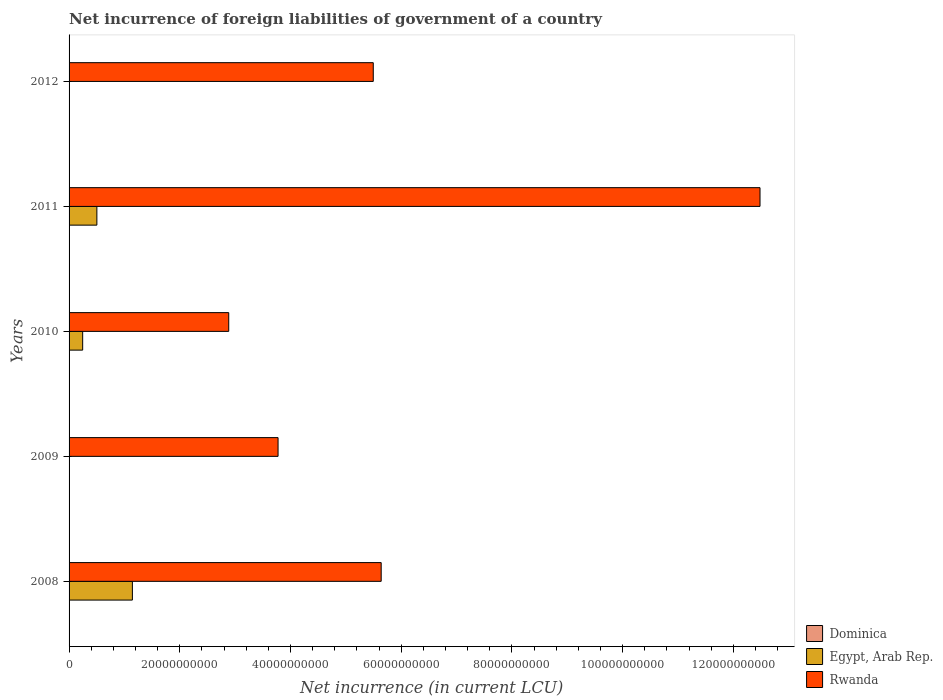How many groups of bars are there?
Ensure brevity in your answer.  5. How many bars are there on the 4th tick from the bottom?
Make the answer very short. 3. What is the net incurrence of foreign liabilities in Egypt, Arab Rep. in 2008?
Provide a short and direct response. 1.14e+1. Across all years, what is the maximum net incurrence of foreign liabilities in Rwanda?
Your answer should be very brief. 1.25e+11. Across all years, what is the minimum net incurrence of foreign liabilities in Dominica?
Your answer should be compact. 0. In which year was the net incurrence of foreign liabilities in Dominica maximum?
Give a very brief answer. 2012. What is the total net incurrence of foreign liabilities in Dominica in the graph?
Give a very brief answer. 1.79e+08. What is the difference between the net incurrence of foreign liabilities in Egypt, Arab Rep. in 2008 and that in 2010?
Your answer should be compact. 8.98e+09. What is the difference between the net incurrence of foreign liabilities in Rwanda in 2009 and the net incurrence of foreign liabilities in Dominica in 2012?
Provide a succinct answer. 3.77e+1. What is the average net incurrence of foreign liabilities in Egypt, Arab Rep. per year?
Your answer should be very brief. 3.78e+09. In the year 2010, what is the difference between the net incurrence of foreign liabilities in Dominica and net incurrence of foreign liabilities in Rwanda?
Your answer should be very brief. -2.88e+1. In how many years, is the net incurrence of foreign liabilities in Rwanda greater than 104000000000 LCU?
Make the answer very short. 1. What is the ratio of the net incurrence of foreign liabilities in Rwanda in 2009 to that in 2011?
Your answer should be very brief. 0.3. What is the difference between the highest and the second highest net incurrence of foreign liabilities in Egypt, Arab Rep.?
Give a very brief answer. 6.42e+09. What is the difference between the highest and the lowest net incurrence of foreign liabilities in Dominica?
Make the answer very short. 7.28e+07. Is the sum of the net incurrence of foreign liabilities in Dominica in 2009 and 2011 greater than the maximum net incurrence of foreign liabilities in Egypt, Arab Rep. across all years?
Your answer should be very brief. No. Are all the bars in the graph horizontal?
Provide a short and direct response. Yes. How many years are there in the graph?
Keep it short and to the point. 5. What is the difference between two consecutive major ticks on the X-axis?
Your answer should be compact. 2.00e+1. Are the values on the major ticks of X-axis written in scientific E-notation?
Offer a terse response. No. Does the graph contain any zero values?
Ensure brevity in your answer.  Yes. Where does the legend appear in the graph?
Provide a succinct answer. Bottom right. How many legend labels are there?
Make the answer very short. 3. What is the title of the graph?
Give a very brief answer. Net incurrence of foreign liabilities of government of a country. Does "Papua New Guinea" appear as one of the legend labels in the graph?
Offer a terse response. No. What is the label or title of the X-axis?
Make the answer very short. Net incurrence (in current LCU). What is the Net incurrence (in current LCU) in Egypt, Arab Rep. in 2008?
Make the answer very short. 1.14e+1. What is the Net incurrence (in current LCU) of Rwanda in 2008?
Ensure brevity in your answer.  5.64e+1. What is the Net incurrence (in current LCU) of Dominica in 2009?
Make the answer very short. 3.07e+07. What is the Net incurrence (in current LCU) in Egypt, Arab Rep. in 2009?
Offer a very short reply. 0. What is the Net incurrence (in current LCU) of Rwanda in 2009?
Offer a very short reply. 3.78e+1. What is the Net incurrence (in current LCU) in Dominica in 2010?
Give a very brief answer. 4.80e+07. What is the Net incurrence (in current LCU) of Egypt, Arab Rep. in 2010?
Offer a terse response. 2.46e+09. What is the Net incurrence (in current LCU) in Rwanda in 2010?
Provide a short and direct response. 2.88e+1. What is the Net incurrence (in current LCU) in Dominica in 2011?
Offer a very short reply. 2.72e+07. What is the Net incurrence (in current LCU) in Egypt, Arab Rep. in 2011?
Your response must be concise. 5.02e+09. What is the Net incurrence (in current LCU) in Rwanda in 2011?
Provide a succinct answer. 1.25e+11. What is the Net incurrence (in current LCU) of Dominica in 2012?
Offer a terse response. 7.28e+07. What is the Net incurrence (in current LCU) of Rwanda in 2012?
Make the answer very short. 5.49e+1. Across all years, what is the maximum Net incurrence (in current LCU) in Dominica?
Ensure brevity in your answer.  7.28e+07. Across all years, what is the maximum Net incurrence (in current LCU) in Egypt, Arab Rep.?
Provide a short and direct response. 1.14e+1. Across all years, what is the maximum Net incurrence (in current LCU) in Rwanda?
Your answer should be very brief. 1.25e+11. Across all years, what is the minimum Net incurrence (in current LCU) of Egypt, Arab Rep.?
Keep it short and to the point. 0. Across all years, what is the minimum Net incurrence (in current LCU) in Rwanda?
Provide a short and direct response. 2.88e+1. What is the total Net incurrence (in current LCU) of Dominica in the graph?
Offer a very short reply. 1.79e+08. What is the total Net incurrence (in current LCU) of Egypt, Arab Rep. in the graph?
Provide a short and direct response. 1.89e+1. What is the total Net incurrence (in current LCU) of Rwanda in the graph?
Your answer should be compact. 3.03e+11. What is the difference between the Net incurrence (in current LCU) of Rwanda in 2008 and that in 2009?
Keep it short and to the point. 1.86e+1. What is the difference between the Net incurrence (in current LCU) in Egypt, Arab Rep. in 2008 and that in 2010?
Your response must be concise. 8.98e+09. What is the difference between the Net incurrence (in current LCU) of Rwanda in 2008 and that in 2010?
Offer a very short reply. 2.75e+1. What is the difference between the Net incurrence (in current LCU) of Egypt, Arab Rep. in 2008 and that in 2011?
Offer a terse response. 6.42e+09. What is the difference between the Net incurrence (in current LCU) of Rwanda in 2008 and that in 2011?
Offer a very short reply. -6.84e+1. What is the difference between the Net incurrence (in current LCU) of Rwanda in 2008 and that in 2012?
Your answer should be compact. 1.43e+09. What is the difference between the Net incurrence (in current LCU) in Dominica in 2009 and that in 2010?
Your answer should be very brief. -1.73e+07. What is the difference between the Net incurrence (in current LCU) of Rwanda in 2009 and that in 2010?
Offer a terse response. 8.91e+09. What is the difference between the Net incurrence (in current LCU) in Dominica in 2009 and that in 2011?
Give a very brief answer. 3.50e+06. What is the difference between the Net incurrence (in current LCU) in Rwanda in 2009 and that in 2011?
Keep it short and to the point. -8.71e+1. What is the difference between the Net incurrence (in current LCU) of Dominica in 2009 and that in 2012?
Make the answer very short. -4.21e+07. What is the difference between the Net incurrence (in current LCU) of Rwanda in 2009 and that in 2012?
Provide a succinct answer. -1.72e+1. What is the difference between the Net incurrence (in current LCU) of Dominica in 2010 and that in 2011?
Give a very brief answer. 2.08e+07. What is the difference between the Net incurrence (in current LCU) of Egypt, Arab Rep. in 2010 and that in 2011?
Ensure brevity in your answer.  -2.56e+09. What is the difference between the Net incurrence (in current LCU) of Rwanda in 2010 and that in 2011?
Offer a very short reply. -9.60e+1. What is the difference between the Net incurrence (in current LCU) of Dominica in 2010 and that in 2012?
Your answer should be very brief. -2.48e+07. What is the difference between the Net incurrence (in current LCU) in Rwanda in 2010 and that in 2012?
Your answer should be very brief. -2.61e+1. What is the difference between the Net incurrence (in current LCU) of Dominica in 2011 and that in 2012?
Your answer should be compact. -4.56e+07. What is the difference between the Net incurrence (in current LCU) of Rwanda in 2011 and that in 2012?
Your answer should be compact. 6.99e+1. What is the difference between the Net incurrence (in current LCU) in Egypt, Arab Rep. in 2008 and the Net incurrence (in current LCU) in Rwanda in 2009?
Offer a very short reply. -2.63e+1. What is the difference between the Net incurrence (in current LCU) of Egypt, Arab Rep. in 2008 and the Net incurrence (in current LCU) of Rwanda in 2010?
Keep it short and to the point. -1.74e+1. What is the difference between the Net incurrence (in current LCU) in Egypt, Arab Rep. in 2008 and the Net incurrence (in current LCU) in Rwanda in 2011?
Your response must be concise. -1.13e+11. What is the difference between the Net incurrence (in current LCU) in Egypt, Arab Rep. in 2008 and the Net incurrence (in current LCU) in Rwanda in 2012?
Offer a terse response. -4.35e+1. What is the difference between the Net incurrence (in current LCU) in Dominica in 2009 and the Net incurrence (in current LCU) in Egypt, Arab Rep. in 2010?
Keep it short and to the point. -2.43e+09. What is the difference between the Net incurrence (in current LCU) of Dominica in 2009 and the Net incurrence (in current LCU) of Rwanda in 2010?
Offer a very short reply. -2.88e+1. What is the difference between the Net incurrence (in current LCU) of Dominica in 2009 and the Net incurrence (in current LCU) of Egypt, Arab Rep. in 2011?
Your response must be concise. -4.99e+09. What is the difference between the Net incurrence (in current LCU) of Dominica in 2009 and the Net incurrence (in current LCU) of Rwanda in 2011?
Provide a short and direct response. -1.25e+11. What is the difference between the Net incurrence (in current LCU) of Dominica in 2009 and the Net incurrence (in current LCU) of Rwanda in 2012?
Your answer should be very brief. -5.49e+1. What is the difference between the Net incurrence (in current LCU) of Dominica in 2010 and the Net incurrence (in current LCU) of Egypt, Arab Rep. in 2011?
Your answer should be very brief. -4.97e+09. What is the difference between the Net incurrence (in current LCU) of Dominica in 2010 and the Net incurrence (in current LCU) of Rwanda in 2011?
Keep it short and to the point. -1.25e+11. What is the difference between the Net incurrence (in current LCU) in Egypt, Arab Rep. in 2010 and the Net incurrence (in current LCU) in Rwanda in 2011?
Make the answer very short. -1.22e+11. What is the difference between the Net incurrence (in current LCU) in Dominica in 2010 and the Net incurrence (in current LCU) in Rwanda in 2012?
Provide a succinct answer. -5.49e+1. What is the difference between the Net incurrence (in current LCU) of Egypt, Arab Rep. in 2010 and the Net incurrence (in current LCU) of Rwanda in 2012?
Give a very brief answer. -5.25e+1. What is the difference between the Net incurrence (in current LCU) in Dominica in 2011 and the Net incurrence (in current LCU) in Rwanda in 2012?
Your answer should be very brief. -5.49e+1. What is the difference between the Net incurrence (in current LCU) of Egypt, Arab Rep. in 2011 and the Net incurrence (in current LCU) of Rwanda in 2012?
Your answer should be compact. -4.99e+1. What is the average Net incurrence (in current LCU) of Dominica per year?
Offer a terse response. 3.57e+07. What is the average Net incurrence (in current LCU) in Egypt, Arab Rep. per year?
Ensure brevity in your answer.  3.78e+09. What is the average Net incurrence (in current LCU) in Rwanda per year?
Ensure brevity in your answer.  6.05e+1. In the year 2008, what is the difference between the Net incurrence (in current LCU) of Egypt, Arab Rep. and Net incurrence (in current LCU) of Rwanda?
Provide a short and direct response. -4.49e+1. In the year 2009, what is the difference between the Net incurrence (in current LCU) in Dominica and Net incurrence (in current LCU) in Rwanda?
Offer a very short reply. -3.77e+1. In the year 2010, what is the difference between the Net incurrence (in current LCU) of Dominica and Net incurrence (in current LCU) of Egypt, Arab Rep.?
Offer a very short reply. -2.41e+09. In the year 2010, what is the difference between the Net incurrence (in current LCU) of Dominica and Net incurrence (in current LCU) of Rwanda?
Make the answer very short. -2.88e+1. In the year 2010, what is the difference between the Net incurrence (in current LCU) of Egypt, Arab Rep. and Net incurrence (in current LCU) of Rwanda?
Ensure brevity in your answer.  -2.64e+1. In the year 2011, what is the difference between the Net incurrence (in current LCU) in Dominica and Net incurrence (in current LCU) in Egypt, Arab Rep.?
Offer a very short reply. -4.99e+09. In the year 2011, what is the difference between the Net incurrence (in current LCU) in Dominica and Net incurrence (in current LCU) in Rwanda?
Provide a short and direct response. -1.25e+11. In the year 2011, what is the difference between the Net incurrence (in current LCU) of Egypt, Arab Rep. and Net incurrence (in current LCU) of Rwanda?
Your response must be concise. -1.20e+11. In the year 2012, what is the difference between the Net incurrence (in current LCU) of Dominica and Net incurrence (in current LCU) of Rwanda?
Give a very brief answer. -5.49e+1. What is the ratio of the Net incurrence (in current LCU) of Rwanda in 2008 to that in 2009?
Your answer should be compact. 1.49. What is the ratio of the Net incurrence (in current LCU) in Egypt, Arab Rep. in 2008 to that in 2010?
Your response must be concise. 4.65. What is the ratio of the Net incurrence (in current LCU) in Rwanda in 2008 to that in 2010?
Provide a succinct answer. 1.95. What is the ratio of the Net incurrence (in current LCU) of Egypt, Arab Rep. in 2008 to that in 2011?
Provide a short and direct response. 2.28. What is the ratio of the Net incurrence (in current LCU) of Rwanda in 2008 to that in 2011?
Your response must be concise. 0.45. What is the ratio of the Net incurrence (in current LCU) of Rwanda in 2008 to that in 2012?
Give a very brief answer. 1.03. What is the ratio of the Net incurrence (in current LCU) in Dominica in 2009 to that in 2010?
Make the answer very short. 0.64. What is the ratio of the Net incurrence (in current LCU) of Rwanda in 2009 to that in 2010?
Your answer should be compact. 1.31. What is the ratio of the Net incurrence (in current LCU) in Dominica in 2009 to that in 2011?
Your answer should be compact. 1.13. What is the ratio of the Net incurrence (in current LCU) in Rwanda in 2009 to that in 2011?
Give a very brief answer. 0.3. What is the ratio of the Net incurrence (in current LCU) of Dominica in 2009 to that in 2012?
Keep it short and to the point. 0.42. What is the ratio of the Net incurrence (in current LCU) of Rwanda in 2009 to that in 2012?
Provide a succinct answer. 0.69. What is the ratio of the Net incurrence (in current LCU) in Dominica in 2010 to that in 2011?
Keep it short and to the point. 1.76. What is the ratio of the Net incurrence (in current LCU) in Egypt, Arab Rep. in 2010 to that in 2011?
Offer a terse response. 0.49. What is the ratio of the Net incurrence (in current LCU) of Rwanda in 2010 to that in 2011?
Ensure brevity in your answer.  0.23. What is the ratio of the Net incurrence (in current LCU) in Dominica in 2010 to that in 2012?
Provide a short and direct response. 0.66. What is the ratio of the Net incurrence (in current LCU) of Rwanda in 2010 to that in 2012?
Provide a short and direct response. 0.52. What is the ratio of the Net incurrence (in current LCU) of Dominica in 2011 to that in 2012?
Provide a short and direct response. 0.37. What is the ratio of the Net incurrence (in current LCU) in Rwanda in 2011 to that in 2012?
Ensure brevity in your answer.  2.27. What is the difference between the highest and the second highest Net incurrence (in current LCU) of Dominica?
Your response must be concise. 2.48e+07. What is the difference between the highest and the second highest Net incurrence (in current LCU) of Egypt, Arab Rep.?
Your answer should be very brief. 6.42e+09. What is the difference between the highest and the second highest Net incurrence (in current LCU) of Rwanda?
Your answer should be very brief. 6.84e+1. What is the difference between the highest and the lowest Net incurrence (in current LCU) in Dominica?
Your answer should be compact. 7.28e+07. What is the difference between the highest and the lowest Net incurrence (in current LCU) in Egypt, Arab Rep.?
Make the answer very short. 1.14e+1. What is the difference between the highest and the lowest Net incurrence (in current LCU) of Rwanda?
Offer a very short reply. 9.60e+1. 